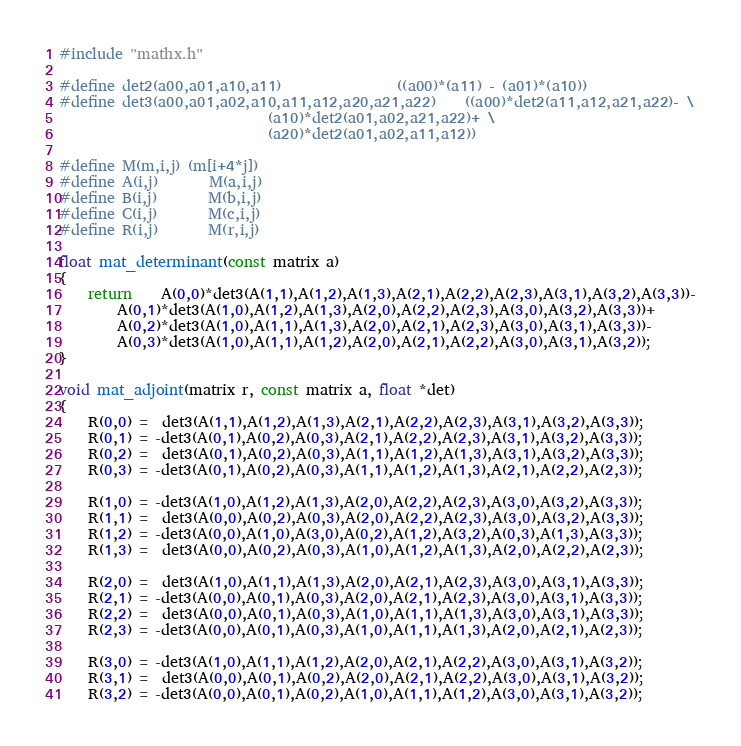<code> <loc_0><loc_0><loc_500><loc_500><_C_>#include "mathx.h"

#define det2(a00,a01,a10,a11)				((a00)*(a11) - (a01)*(a10))
#define det3(a00,a01,a02,a10,a11,a12,a20,a21,a22)	((a00)*det2(a11,a12,a21,a22)- \
							 (a10)*det2(a01,a02,a21,a22)+ \
							 (a20)*det2(a01,a02,a11,a12))

#define M(m,i,j)	(m[i+4*j])
#define A(i,j)		M(a,i,j)
#define B(i,j)		M(b,i,j)
#define C(i,j)		M(c,i,j)
#define R(i,j)		M(r,i,j)

float mat_determinant(const matrix a)
{
	return	A(0,0)*det3(A(1,1),A(1,2),A(1,3),A(2,1),A(2,2),A(2,3),A(3,1),A(3,2),A(3,3))-
		A(0,1)*det3(A(1,0),A(1,2),A(1,3),A(2,0),A(2,2),A(2,3),A(3,0),A(3,2),A(3,3))+
		A(0,2)*det3(A(1,0),A(1,1),A(1,3),A(2,0),A(2,1),A(2,3),A(3,0),A(3,1),A(3,3))-
		A(0,3)*det3(A(1,0),A(1,1),A(1,2),A(2,0),A(2,1),A(2,2),A(3,0),A(3,1),A(3,2));
}

void mat_adjoint(matrix r, const matrix a, float *det)
{
	R(0,0) =  det3(A(1,1),A(1,2),A(1,3),A(2,1),A(2,2),A(2,3),A(3,1),A(3,2),A(3,3));
	R(0,1) = -det3(A(0,1),A(0,2),A(0,3),A(2,1),A(2,2),A(2,3),A(3,1),A(3,2),A(3,3));
	R(0,2) =  det3(A(0,1),A(0,2),A(0,3),A(1,1),A(1,2),A(1,3),A(3,1),A(3,2),A(3,3));
	R(0,3) = -det3(A(0,1),A(0,2),A(0,3),A(1,1),A(1,2),A(1,3),A(2,1),A(2,2),A(2,3));

	R(1,0) = -det3(A(1,0),A(1,2),A(1,3),A(2,0),A(2,2),A(2,3),A(3,0),A(3,2),A(3,3));
	R(1,1) =  det3(A(0,0),A(0,2),A(0,3),A(2,0),A(2,2),A(2,3),A(3,0),A(3,2),A(3,3));
	R(1,2) = -det3(A(0,0),A(1,0),A(3,0),A(0,2),A(1,2),A(3,2),A(0,3),A(1,3),A(3,3));
	R(1,3) =  det3(A(0,0),A(0,2),A(0,3),A(1,0),A(1,2),A(1,3),A(2,0),A(2,2),A(2,3));

	R(2,0) =  det3(A(1,0),A(1,1),A(1,3),A(2,0),A(2,1),A(2,3),A(3,0),A(3,1),A(3,3));
	R(2,1) = -det3(A(0,0),A(0,1),A(0,3),A(2,0),A(2,1),A(2,3),A(3,0),A(3,1),A(3,3));
	R(2,2) =  det3(A(0,0),A(0,1),A(0,3),A(1,0),A(1,1),A(1,3),A(3,0),A(3,1),A(3,3));
	R(2,3) = -det3(A(0,0),A(0,1),A(0,3),A(1,0),A(1,1),A(1,3),A(2,0),A(2,1),A(2,3));

	R(3,0) = -det3(A(1,0),A(1,1),A(1,2),A(2,0),A(2,1),A(2,2),A(3,0),A(3,1),A(3,2));
	R(3,1) =  det3(A(0,0),A(0,1),A(0,2),A(2,0),A(2,1),A(2,2),A(3,0),A(3,1),A(3,2));
	R(3,2) = -det3(A(0,0),A(0,1),A(0,2),A(1,0),A(1,1),A(1,2),A(3,0),A(3,1),A(3,2));</code> 